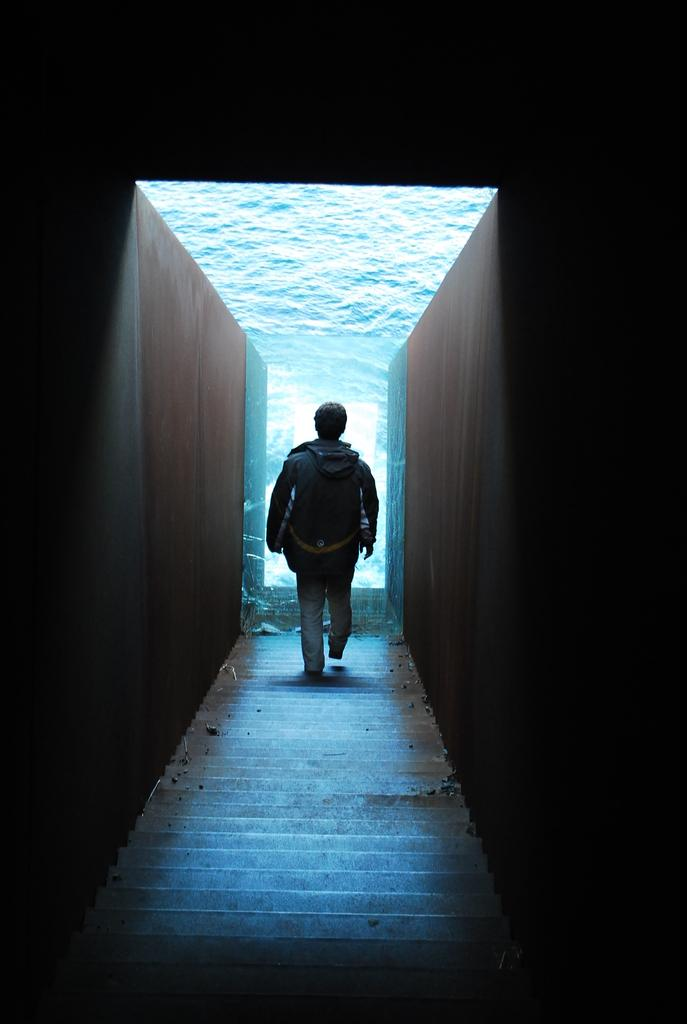What is happening in the image? There is a person in the image, and they are walking on stairs. What can be seen on both sides of the stairs? There are walls on both sides of the stairs. What is the person carrying while walking on the stairs? The person is carrying a bag. Is the person a beginner at walking on stairs, as indicated by the note on the wall? There is no note present in the image, and therefore no indication of the person's experience with walking on stairs. 